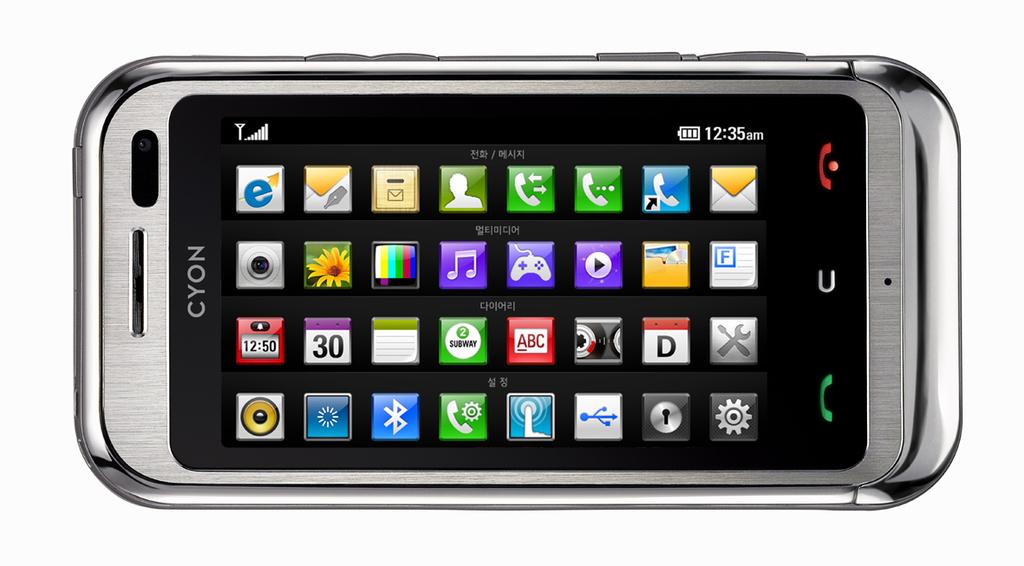What brand of phone is this?
Your answer should be compact. Cyon. What time is shown?
Your answer should be compact. 12:35am. 